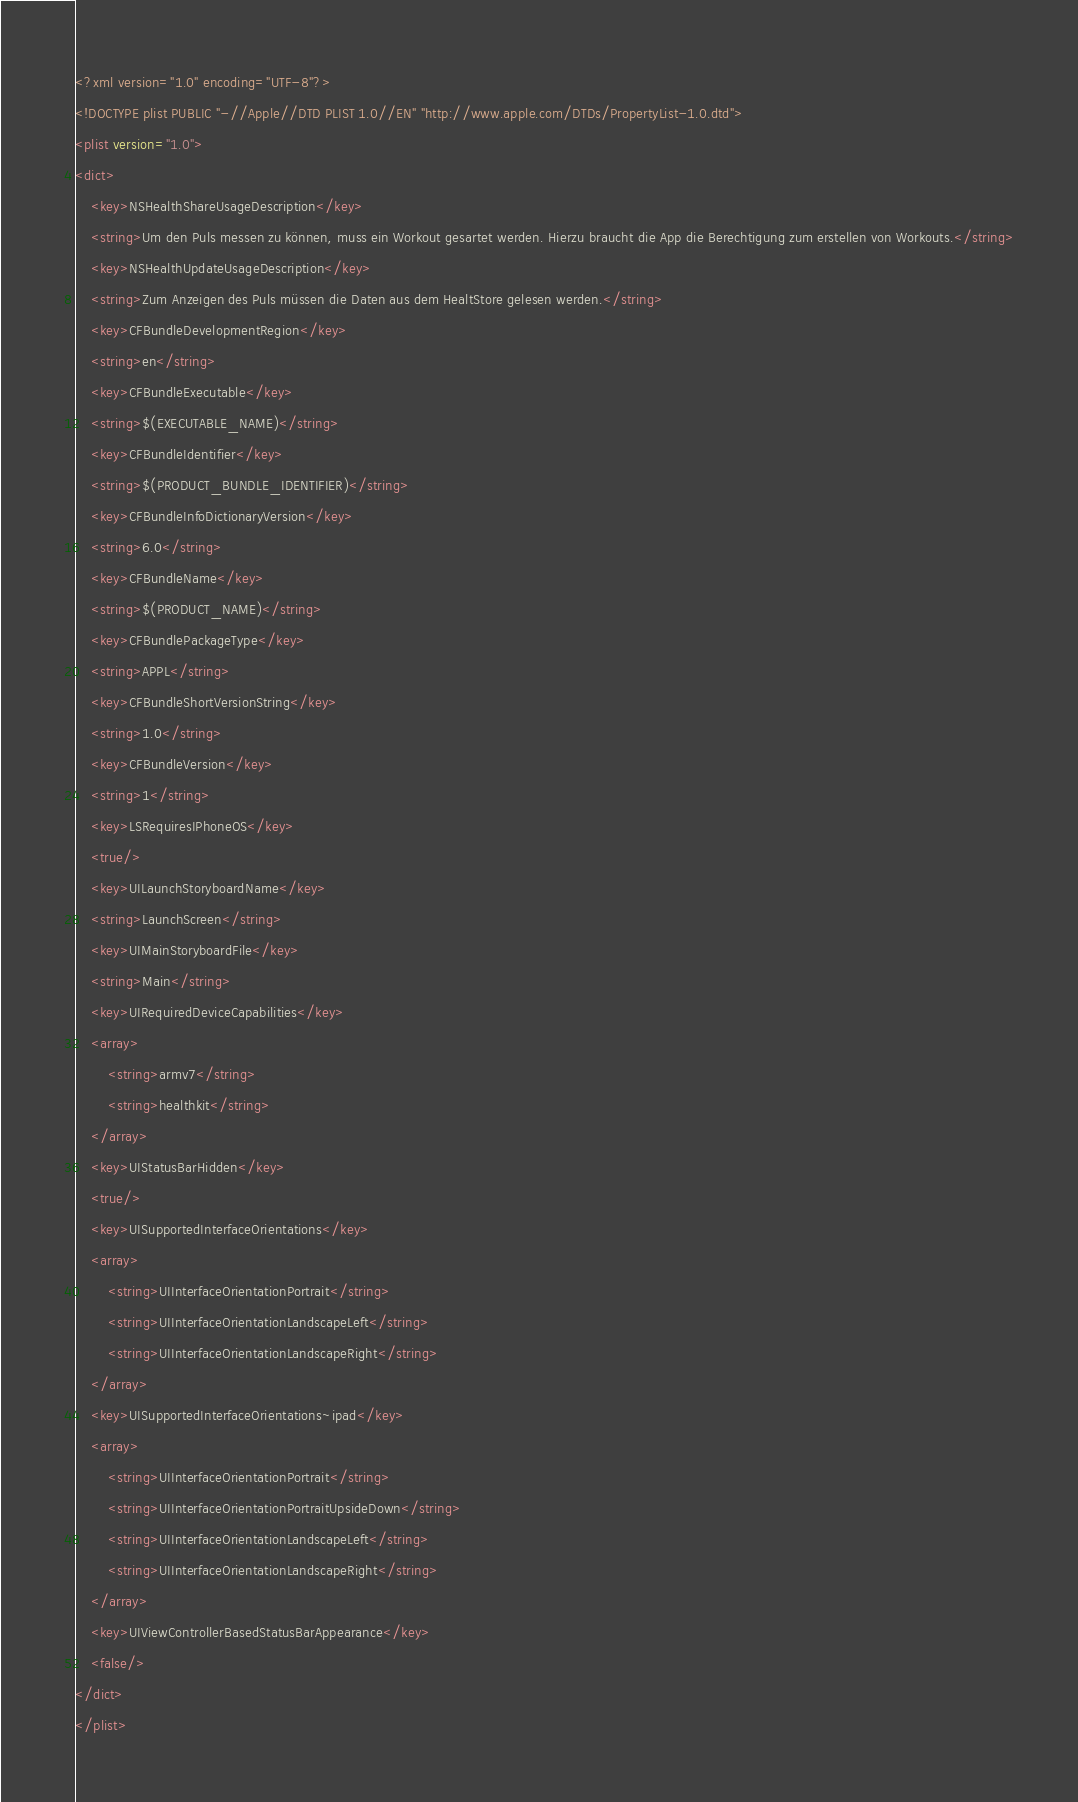<code> <loc_0><loc_0><loc_500><loc_500><_XML_><?xml version="1.0" encoding="UTF-8"?>
<!DOCTYPE plist PUBLIC "-//Apple//DTD PLIST 1.0//EN" "http://www.apple.com/DTDs/PropertyList-1.0.dtd">
<plist version="1.0">
<dict>
	<key>NSHealthShareUsageDescription</key>
	<string>Um den Puls messen zu können, muss ein Workout gesartet werden. Hierzu braucht die App die Berechtigung zum erstellen von Workouts.</string>
	<key>NSHealthUpdateUsageDescription</key>
	<string>Zum Anzeigen des Puls müssen die Daten aus dem HealtStore gelesen werden.</string>
	<key>CFBundleDevelopmentRegion</key>
	<string>en</string>
	<key>CFBundleExecutable</key>
	<string>$(EXECUTABLE_NAME)</string>
	<key>CFBundleIdentifier</key>
	<string>$(PRODUCT_BUNDLE_IDENTIFIER)</string>
	<key>CFBundleInfoDictionaryVersion</key>
	<string>6.0</string>
	<key>CFBundleName</key>
	<string>$(PRODUCT_NAME)</string>
	<key>CFBundlePackageType</key>
	<string>APPL</string>
	<key>CFBundleShortVersionString</key>
	<string>1.0</string>
	<key>CFBundleVersion</key>
	<string>1</string>
	<key>LSRequiresIPhoneOS</key>
	<true/>
	<key>UILaunchStoryboardName</key>
	<string>LaunchScreen</string>
	<key>UIMainStoryboardFile</key>
	<string>Main</string>
	<key>UIRequiredDeviceCapabilities</key>
	<array>
		<string>armv7</string>
		<string>healthkit</string>
	</array>
	<key>UIStatusBarHidden</key>
	<true/>
	<key>UISupportedInterfaceOrientations</key>
	<array>
		<string>UIInterfaceOrientationPortrait</string>
		<string>UIInterfaceOrientationLandscapeLeft</string>
		<string>UIInterfaceOrientationLandscapeRight</string>
	</array>
	<key>UISupportedInterfaceOrientations~ipad</key>
	<array>
		<string>UIInterfaceOrientationPortrait</string>
		<string>UIInterfaceOrientationPortraitUpsideDown</string>
		<string>UIInterfaceOrientationLandscapeLeft</string>
		<string>UIInterfaceOrientationLandscapeRight</string>
	</array>
	<key>UIViewControllerBasedStatusBarAppearance</key>
	<false/>
</dict>
</plist>
</code> 